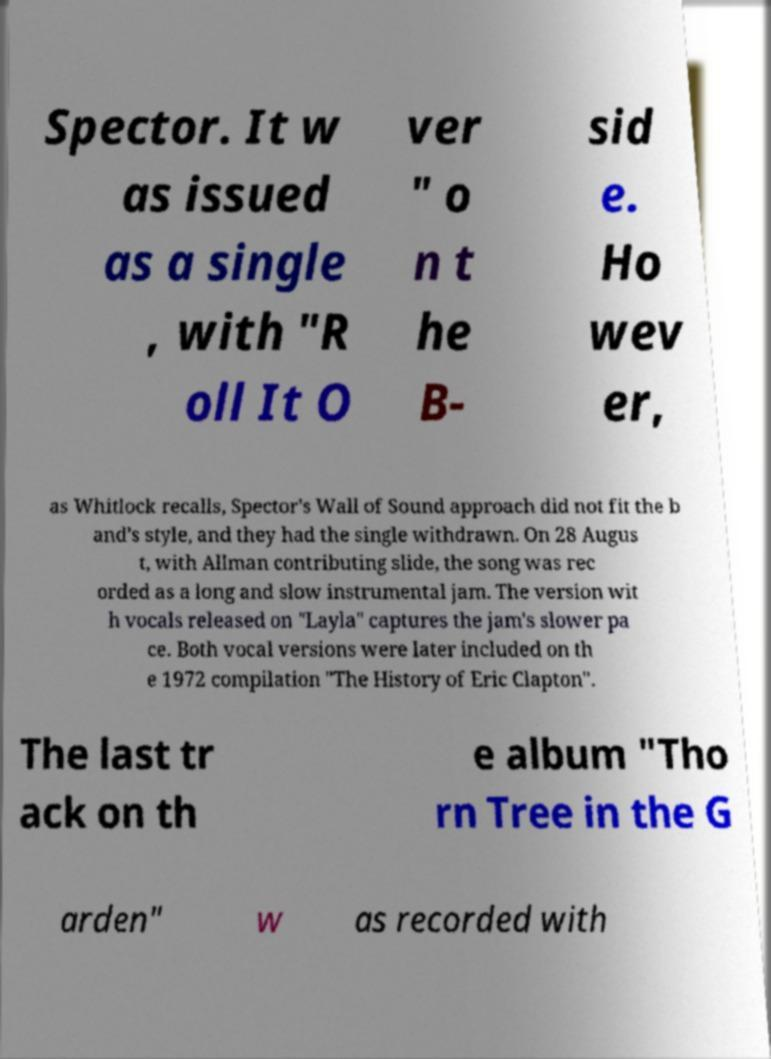Please identify and transcribe the text found in this image. Spector. It w as issued as a single , with "R oll It O ver " o n t he B- sid e. Ho wev er, as Whitlock recalls, Spector's Wall of Sound approach did not fit the b and's style, and they had the single withdrawn. On 28 Augus t, with Allman contributing slide, the song was rec orded as a long and slow instrumental jam. The version wit h vocals released on "Layla" captures the jam's slower pa ce. Both vocal versions were later included on th e 1972 compilation "The History of Eric Clapton". The last tr ack on th e album "Tho rn Tree in the G arden" w as recorded with 